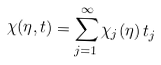Convert formula to latex. <formula><loc_0><loc_0><loc_500><loc_500>\chi ( \eta , t ) = \sum _ { j = 1 } ^ { \infty } \chi _ { j } ( \eta ) \, t _ { j }</formula> 